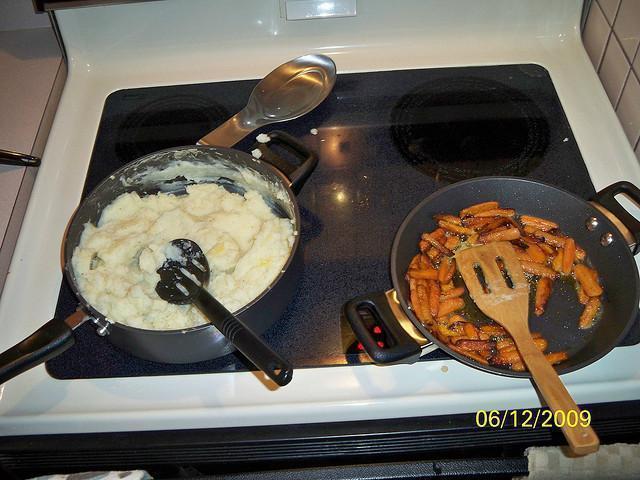What is the silver object above the mashed potatoes pan used for?
Answer the question by selecting the correct answer among the 4 following choices and explain your choice with a short sentence. The answer should be formatted with the following format: `Answer: choice
Rationale: rationale.`
Options: Spoon rest, medicine, stirring, serving. Answer: spoon rest.
Rationale: A flat object with a depression in it is on the stove. 